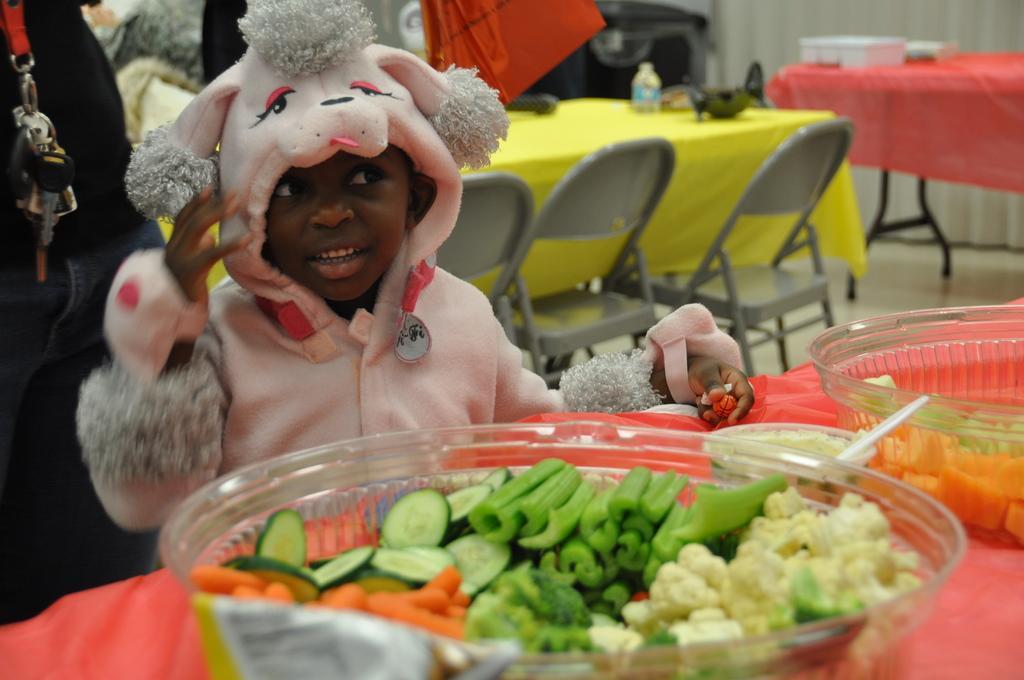How would you summarize this image in a sentence or two? There are vegetables in the bowl, here a child is standing, there are tables and chairs, this is bottle. 